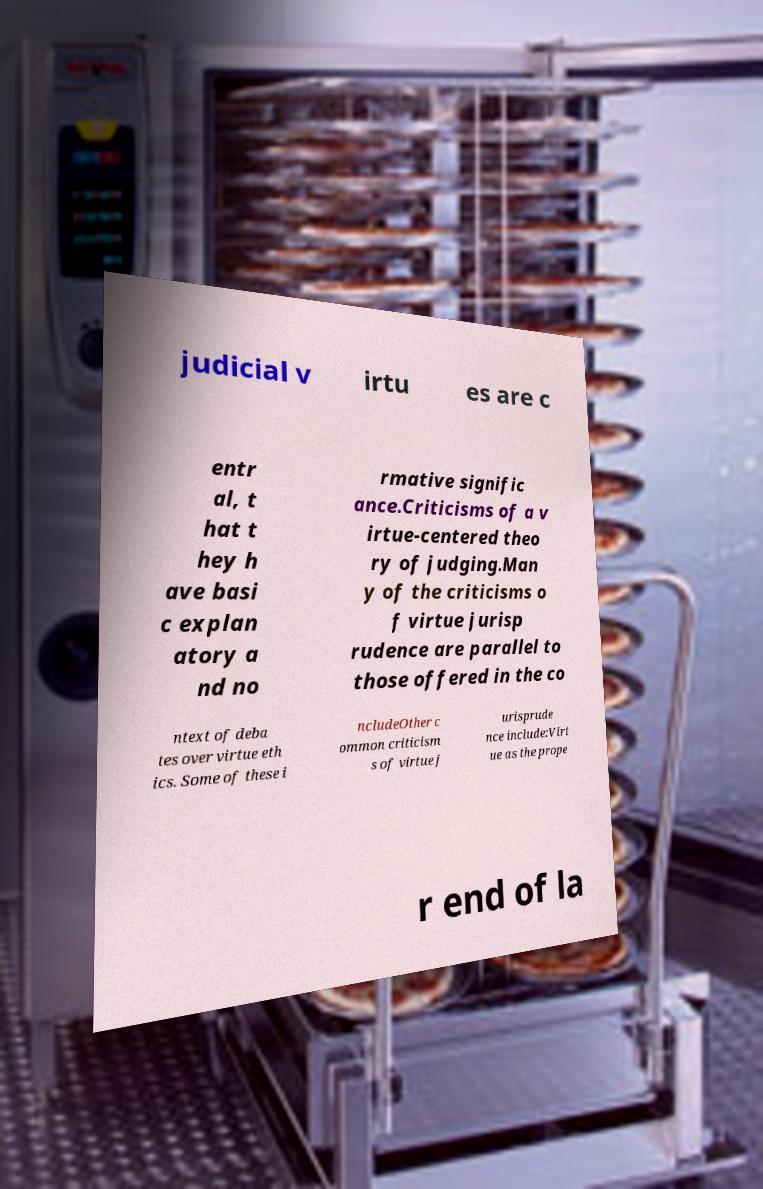There's text embedded in this image that I need extracted. Can you transcribe it verbatim? judicial v irtu es are c entr al, t hat t hey h ave basi c explan atory a nd no rmative signific ance.Criticisms of a v irtue-centered theo ry of judging.Man y of the criticisms o f virtue jurisp rudence are parallel to those offered in the co ntext of deba tes over virtue eth ics. Some of these i ncludeOther c ommon criticism s of virtue j urisprude nce include:Virt ue as the prope r end of la 